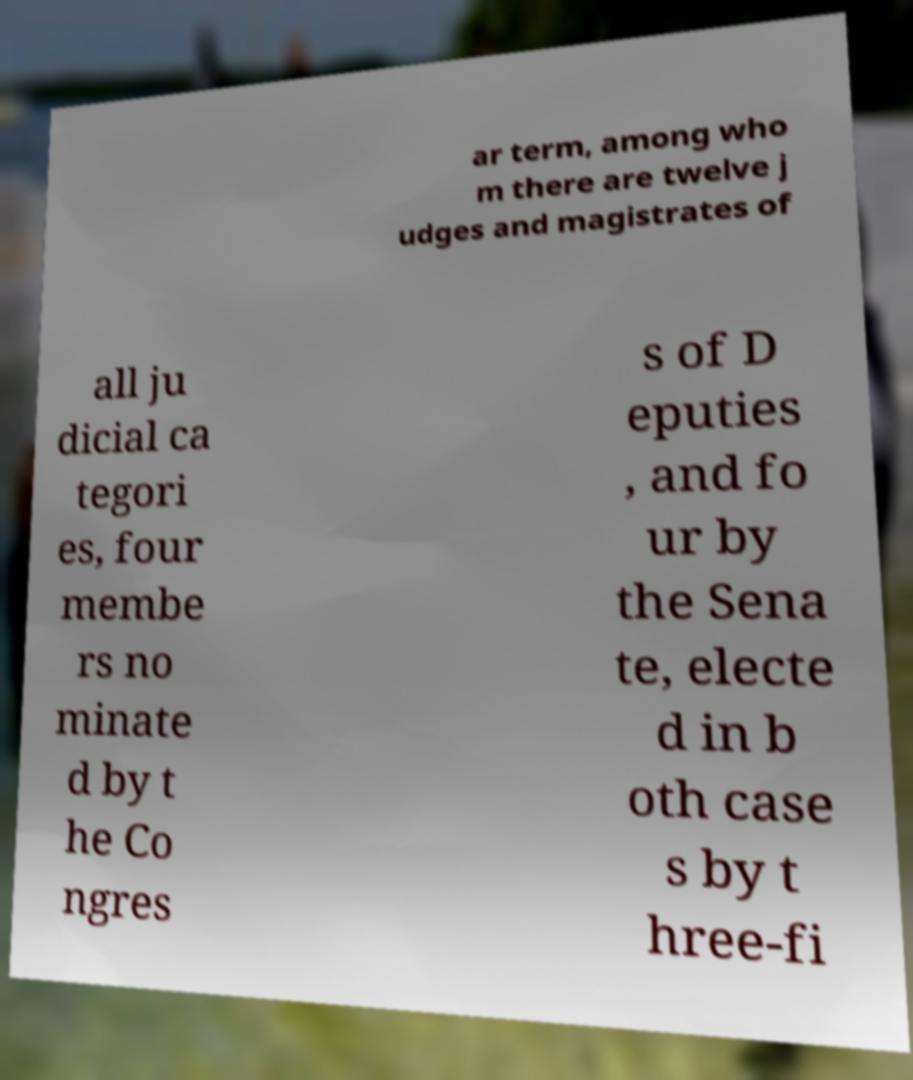What messages or text are displayed in this image? I need them in a readable, typed format. ar term, among who m there are twelve j udges and magistrates of all ju dicial ca tegori es, four membe rs no minate d by t he Co ngres s of D eputies , and fo ur by the Sena te, electe d in b oth case s by t hree-fi 